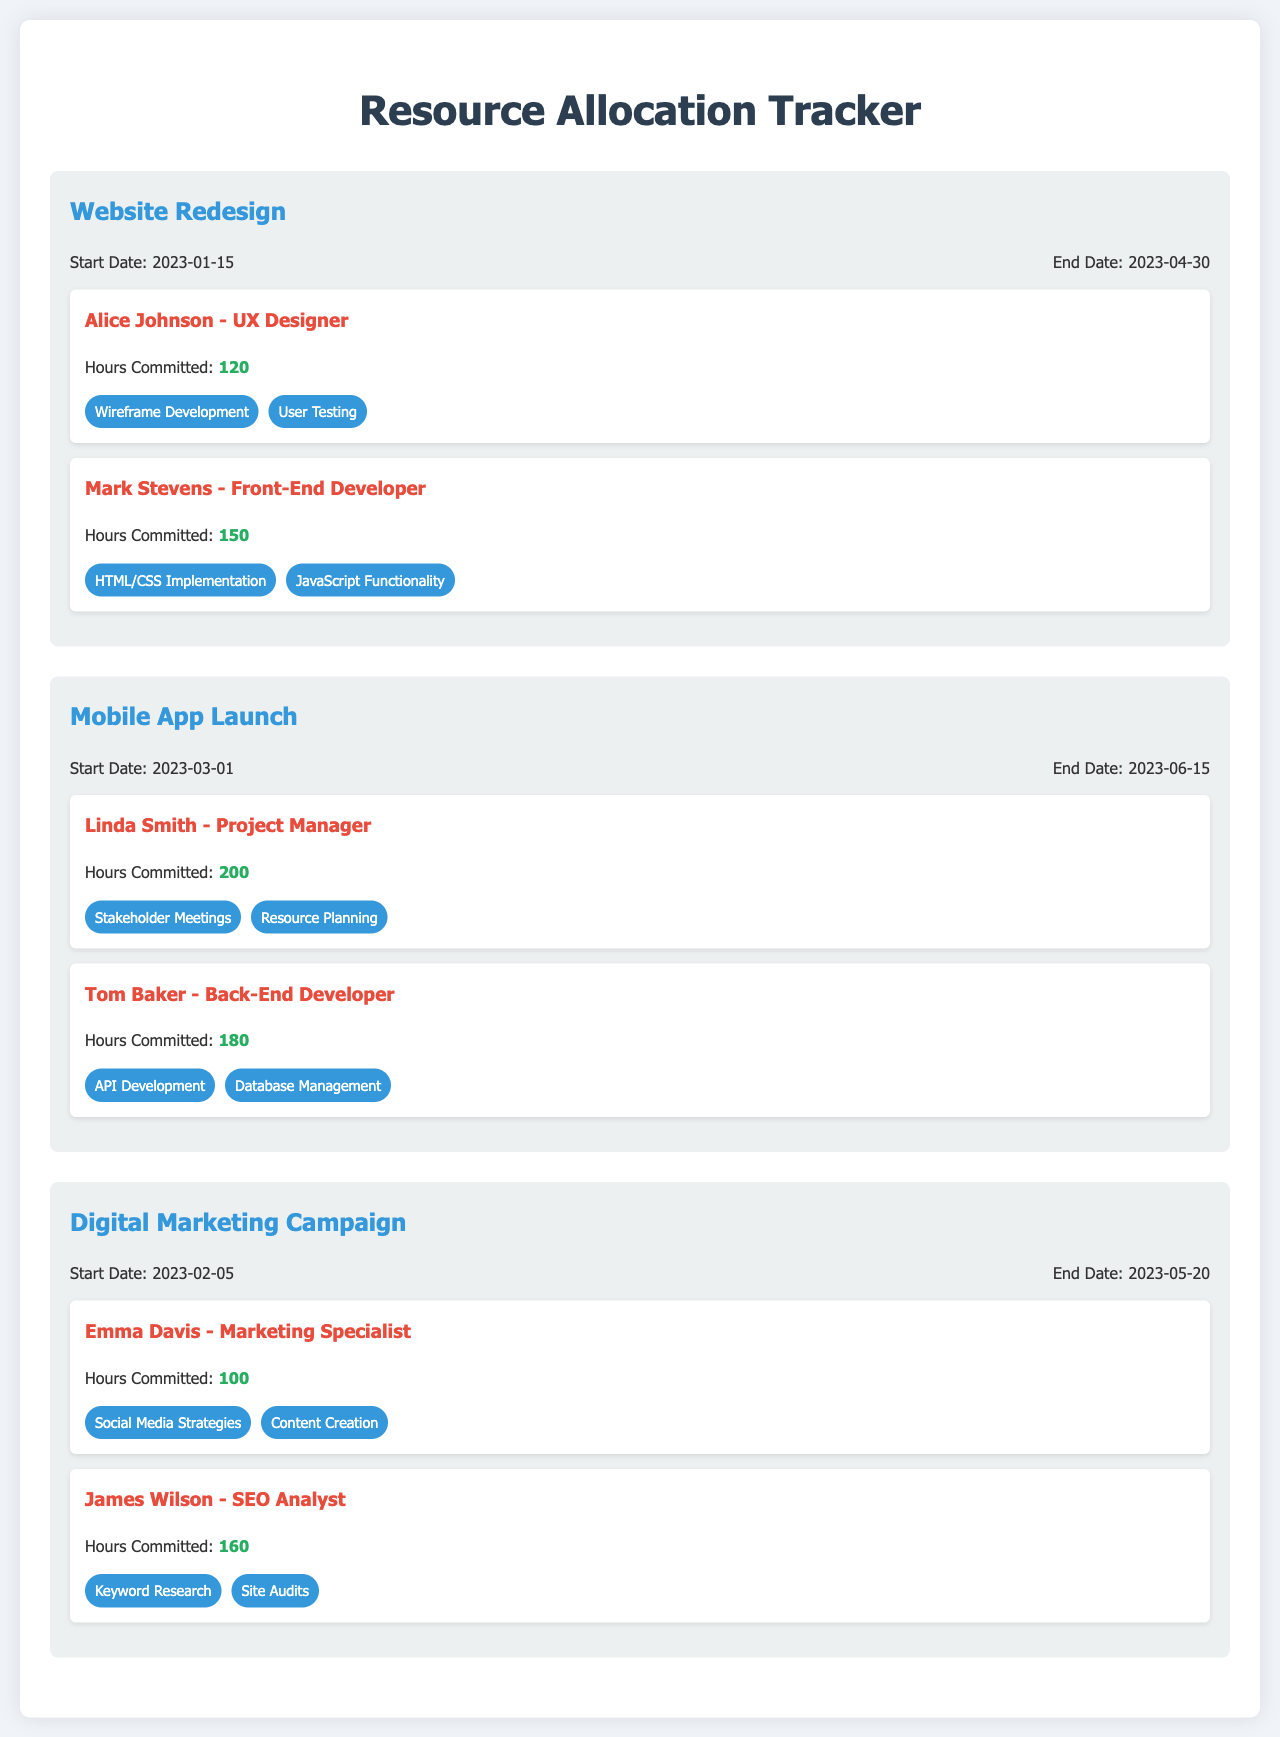What is the start date of the Website Redesign project? The start date is listed in the project information for the Website Redesign project as January 15, 2023.
Answer: January 15, 2023 How many hours has Linda Smith committed to the Mobile App Launch project? Linda Smith's committed hours are specifically mentioned as 200 hours in the personnel section of the Mobile App Launch project.
Answer: 200 Who is the project manager for the Mobile App Launch? The project manager is noted in the document as Linda Smith under the personnel section for the Mobile App Launch project.
Answer: Linda Smith What are the tasks assigned to Tom Baker? The tasks for Tom Baker are provided in the personnel section of the Mobile App Launch project, stating “API Development” and “Database Management.”
Answer: API Development, Database Management Which personnel is assigned to the Digital Marketing Campaign for keyword research? The specific personnel assigned for keyword research is mentioned as James Wilson in the personnel section of the Digital Marketing Campaign project.
Answer: James Wilson What is the end date for the Digital Marketing Campaign project? The end date is specified in the project information for the Digital Marketing Campaign as May 20, 2023.
Answer: May 20, 2023 What is the total number of hours committed across all personnel in the Website Redesign project? The hours committed for Alice Johnson and Mark Stevens are 120 and 150 respectively, summing to 270 hours in total for the Website Redesign project.
Answer: 270 When does the Mobile App Launch project begin? The beginning date for the Mobile App Launch project is found in its project information section as March 1, 2023.
Answer: March 1, 2023 How many personnel are assigned to the Digital Marketing Campaign? The document lists two personnel assigned to the Digital Marketing Campaign, specifically Emma Davis and James Wilson.
Answer: Two 